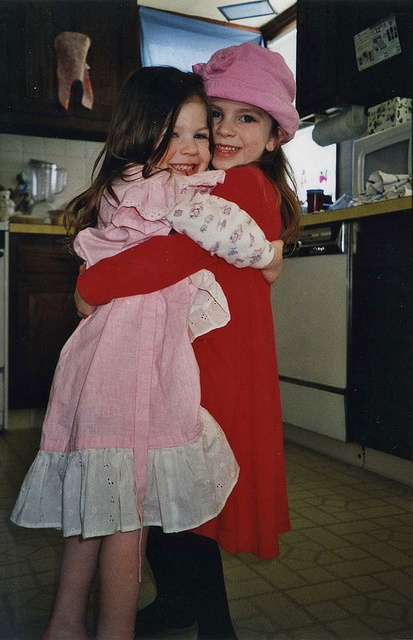Describe the objects in this image and their specific colors. I can see people in black, darkgray, and gray tones, people in black, maroon, and brown tones, refrigerator in black, gray, and darkgreen tones, oven in black, gray, darkgreen, and maroon tones, and microwave in black, gray, and purple tones in this image. 